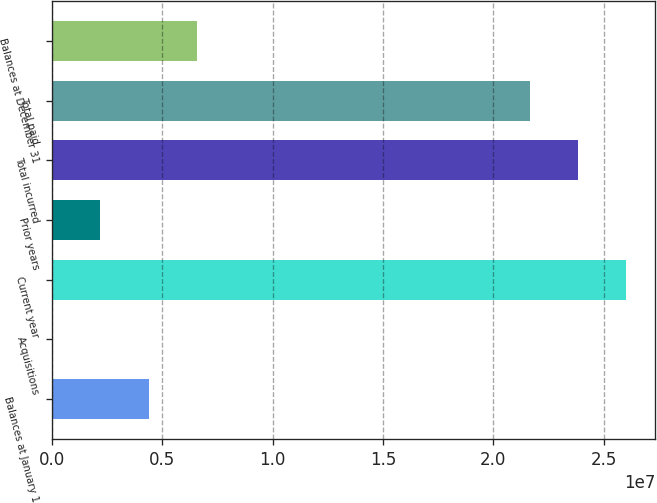Convert chart. <chart><loc_0><loc_0><loc_500><loc_500><bar_chart><fcel>Balances at January 1<fcel>Acquisitions<fcel>Current year<fcel>Prior years<fcel>Total incurred<fcel>Total paid<fcel>Balances at December 31<nl><fcel>4.38699e+06<fcel>0.46<fcel>2.60246e+07<fcel>2.1935e+06<fcel>2.38311e+07<fcel>2.16376e+07<fcel>6.58049e+06<nl></chart> 